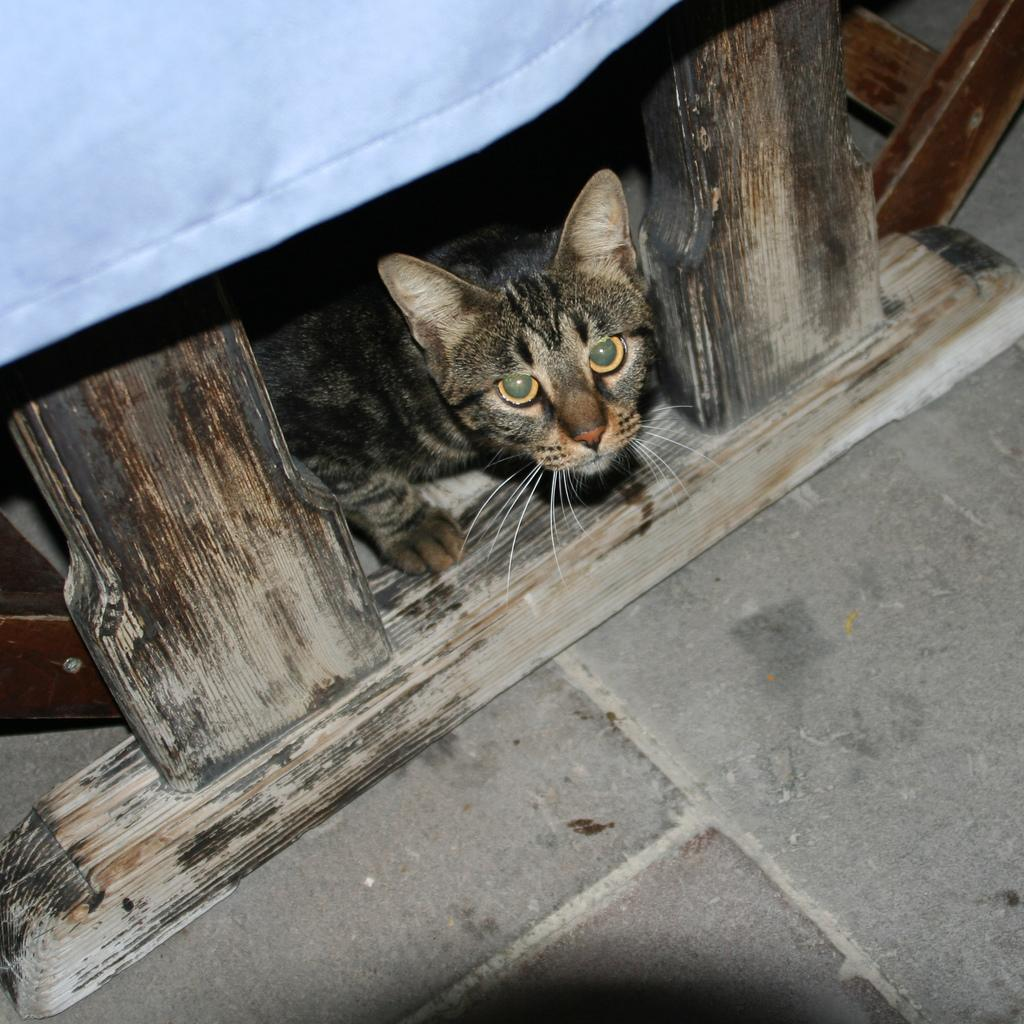What is the main subject in the center of the image? There is a cat in the center of the image. What objects can be seen besides the cat? There are wooden sticks and a cloth in the image. What type of surface is visible at the bottom of the image? The floor is visible at the bottom of the image. What type of brass instrument is being played by the cat in the image? There is no brass instrument or any indication of music in the image; it features a cat, wooden sticks, and a cloth. 